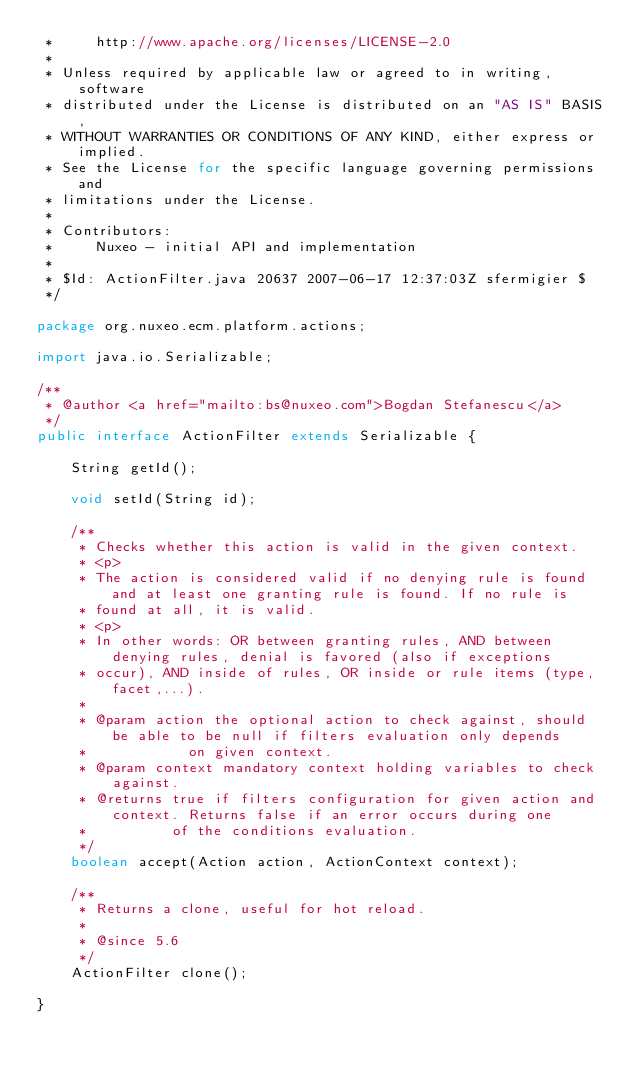Convert code to text. <code><loc_0><loc_0><loc_500><loc_500><_Java_> *     http://www.apache.org/licenses/LICENSE-2.0
 *
 * Unless required by applicable law or agreed to in writing, software
 * distributed under the License is distributed on an "AS IS" BASIS,
 * WITHOUT WARRANTIES OR CONDITIONS OF ANY KIND, either express or implied.
 * See the License for the specific language governing permissions and
 * limitations under the License.
 *
 * Contributors:
 *     Nuxeo - initial API and implementation
 *
 * $Id: ActionFilter.java 20637 2007-06-17 12:37:03Z sfermigier $
 */

package org.nuxeo.ecm.platform.actions;

import java.io.Serializable;

/**
 * @author <a href="mailto:bs@nuxeo.com">Bogdan Stefanescu</a>
 */
public interface ActionFilter extends Serializable {

    String getId();

    void setId(String id);

    /**
     * Checks whether this action is valid in the given context.
     * <p>
     * The action is considered valid if no denying rule is found and at least one granting rule is found. If no rule is
     * found at all, it is valid.
     * <p>
     * In other words: OR between granting rules, AND between denying rules, denial is favored (also if exceptions
     * occur), AND inside of rules, OR inside or rule items (type, facet,...).
     *
     * @param action the optional action to check against, should be able to be null if filters evaluation only depends
     *            on given context.
     * @param context mandatory context holding variables to check against.
     * @returns true if filters configuration for given action and context. Returns false if an error occurs during one
     *          of the conditions evaluation.
     */
    boolean accept(Action action, ActionContext context);

    /**
     * Returns a clone, useful for hot reload.
     *
     * @since 5.6
     */
    ActionFilter clone();

}
</code> 